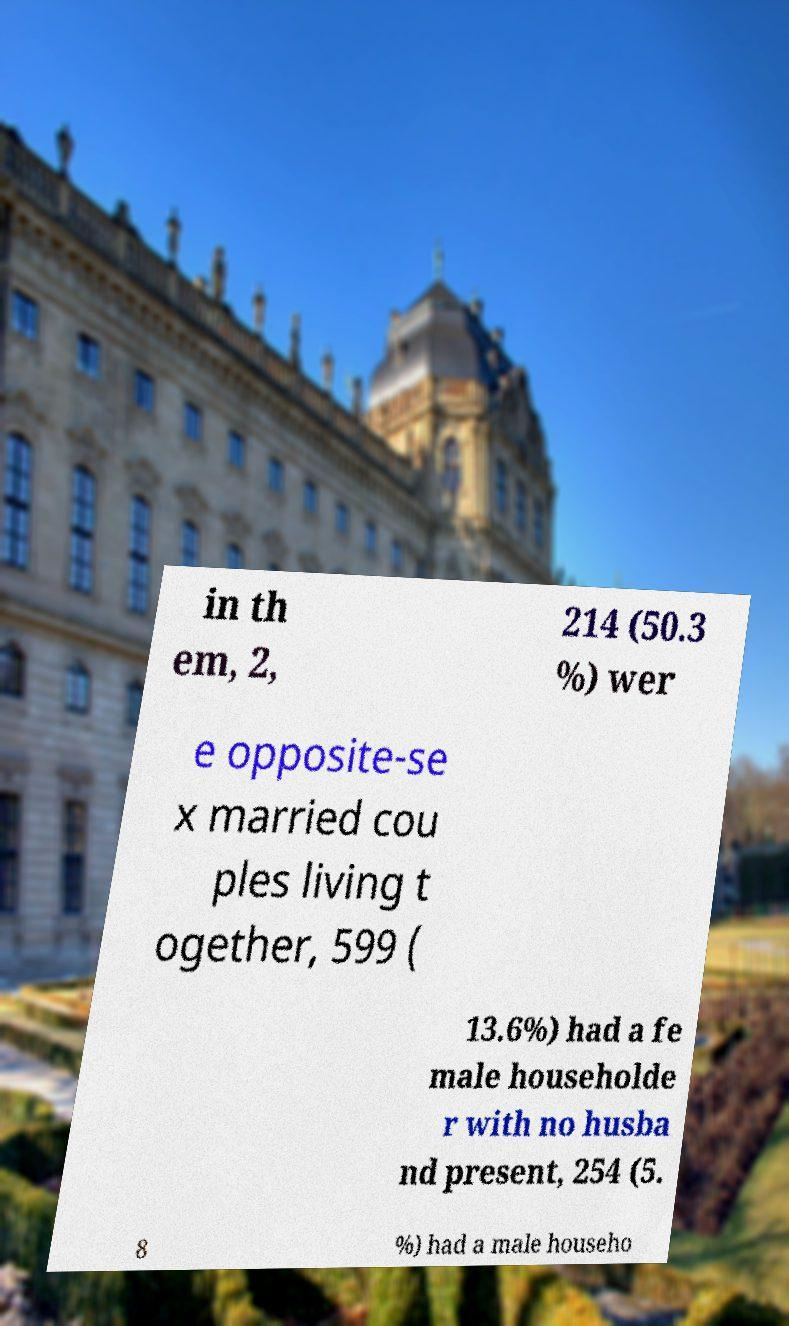Please identify and transcribe the text found in this image. in th em, 2, 214 (50.3 %) wer e opposite-se x married cou ples living t ogether, 599 ( 13.6%) had a fe male householde r with no husba nd present, 254 (5. 8 %) had a male househo 